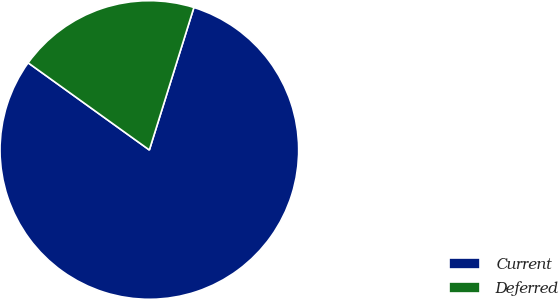Convert chart. <chart><loc_0><loc_0><loc_500><loc_500><pie_chart><fcel>Current<fcel>Deferred<nl><fcel>80.1%<fcel>19.9%<nl></chart> 